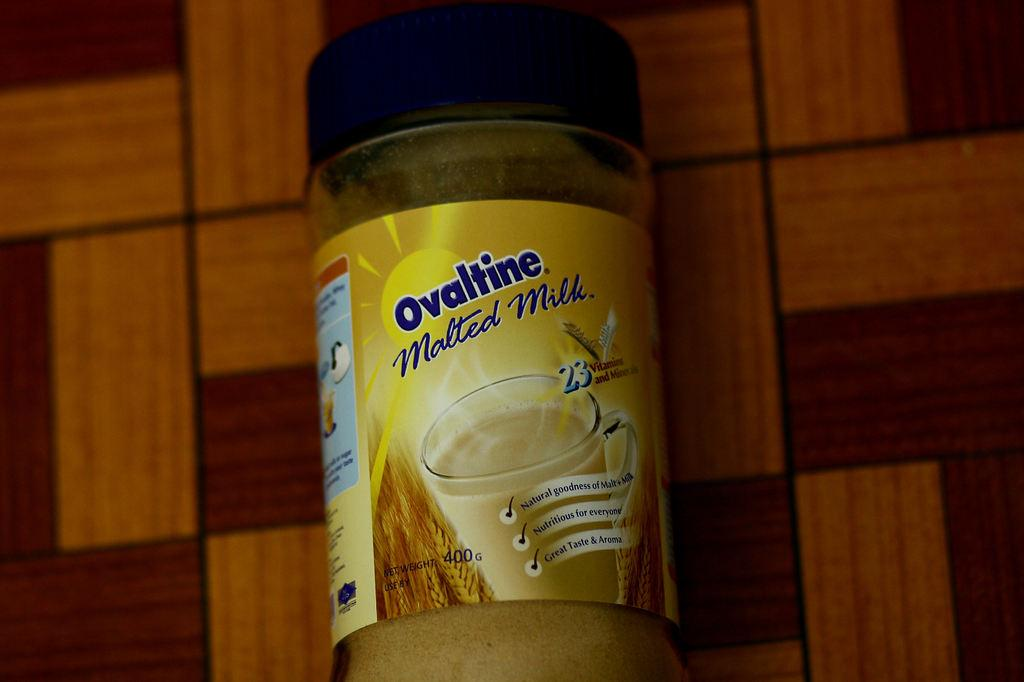<image>
Share a concise interpretation of the image provided. A jar of Ovaltine Malted Milk has a bright yellow sun depicted on it. 